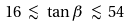<formula> <loc_0><loc_0><loc_500><loc_500>1 6 \ { \lesssim } \ \tan { \beta } \ { \lesssim } \ 5 4</formula> 